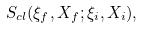Convert formula to latex. <formula><loc_0><loc_0><loc_500><loc_500>S _ { c l } ( \xi _ { f } , X _ { f } ; \xi _ { i } , X _ { i } ) ,</formula> 